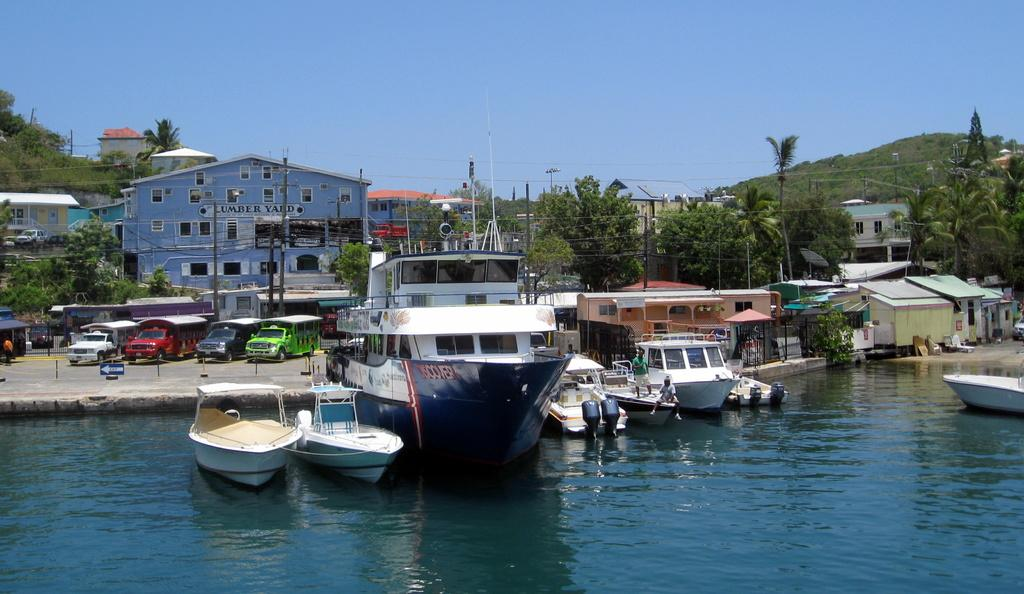What is the main subject of the image? The main subject of the image is boats and ships. Where are the boats and ships located? The boats and ships are on the water. What can be seen in the background of the image? In the background of the image, there are houses, poles, vehicles, and trees. What type of game is being played on the boats and ships in the image? There is no game being played on the boats and ships in the image; they are simply on the water. 